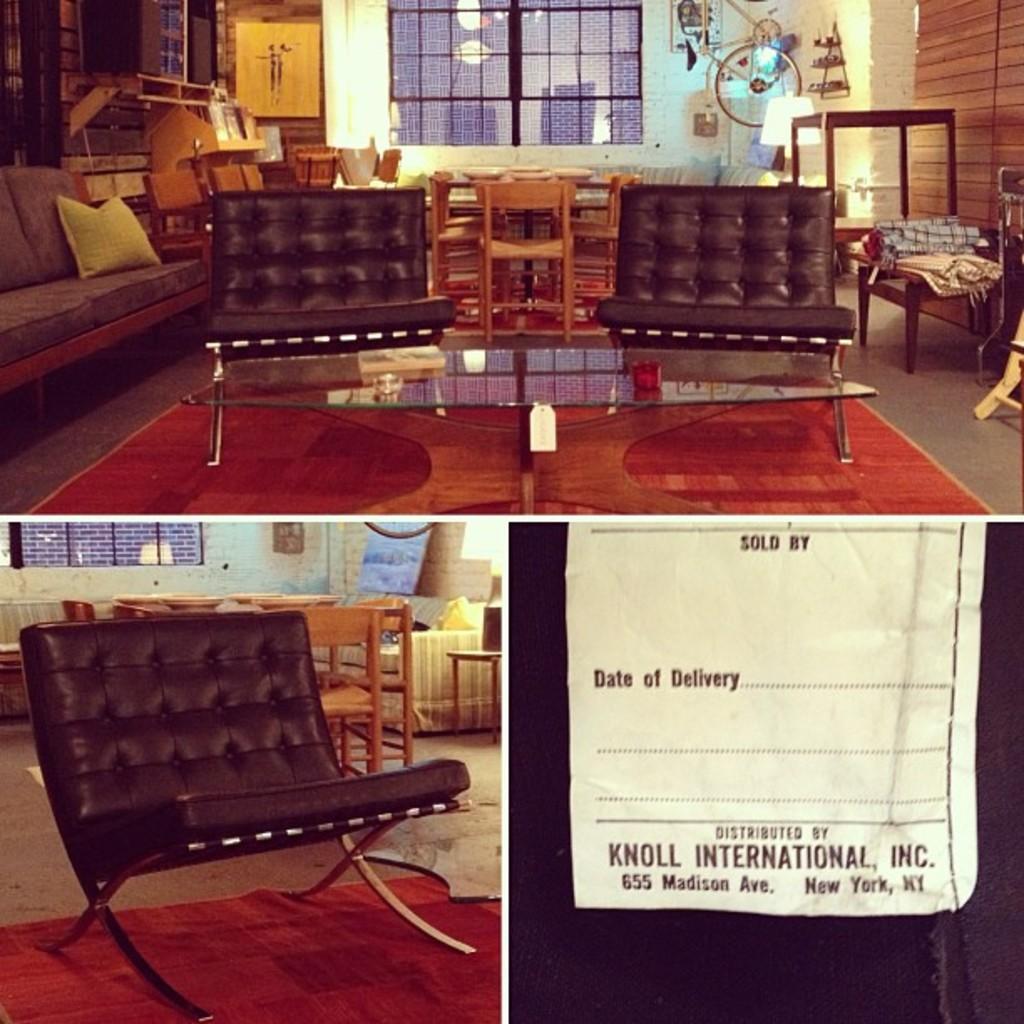Describe this image in one or two sentences. In this picture there are three photographs are collaged. In the first picture there are sofas, chairs and a window. In the second picture there is a sofa and chairs. In the third picture there is a paper and some text printed on it. 